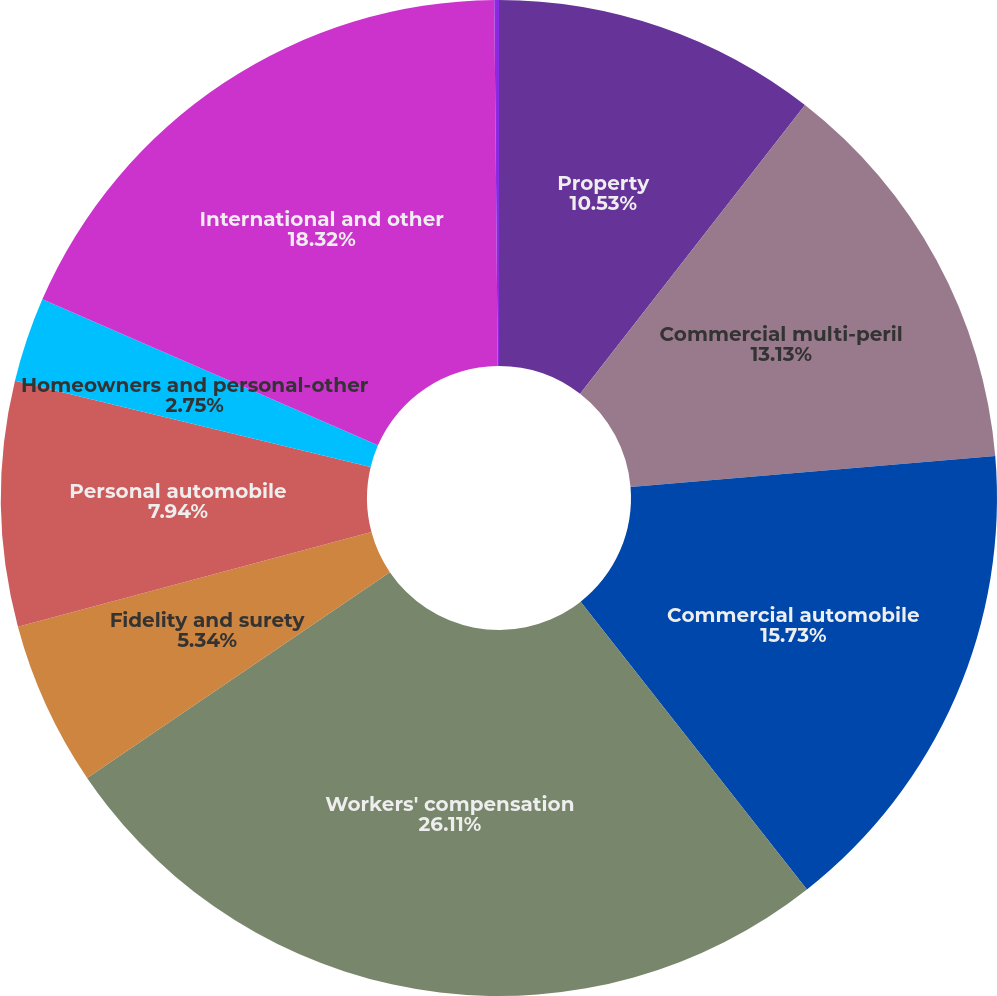<chart> <loc_0><loc_0><loc_500><loc_500><pie_chart><fcel>Property<fcel>Commercial multi-peril<fcel>Commercial automobile<fcel>Workers' compensation<fcel>Fidelity and surety<fcel>Personal automobile<fcel>Homeowners and personal-other<fcel>International and other<fcel>Accident andhealth<nl><fcel>10.53%<fcel>13.13%<fcel>15.73%<fcel>26.11%<fcel>5.34%<fcel>7.94%<fcel>2.75%<fcel>18.32%<fcel>0.15%<nl></chart> 